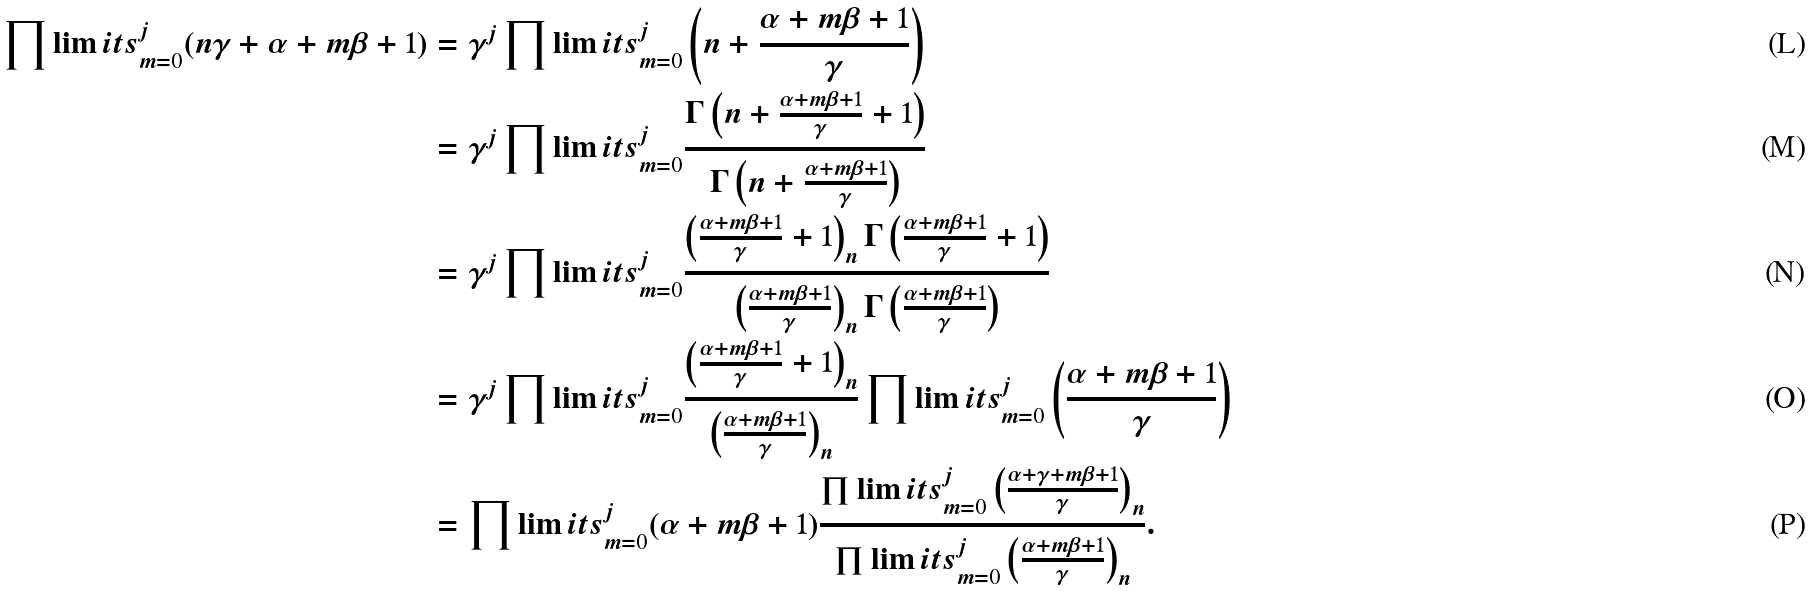Convert formula to latex. <formula><loc_0><loc_0><loc_500><loc_500>\prod \lim i t s _ { m = 0 } ^ { j } ( n \gamma + \alpha + m \beta + 1 ) & = \gamma ^ { j } \prod \lim i t s _ { m = 0 } ^ { j } \left ( n + \frac { \alpha + m \beta + 1 } { \gamma } \right ) \\ & = \gamma ^ { j } \prod \lim i t s _ { m = 0 } ^ { j } \frac { \Gamma \left ( n + \frac { \alpha + m \beta + 1 } { \gamma } + 1 \right ) } { \Gamma \left ( n + \frac { \alpha + m \beta + 1 } { \gamma } \right ) } \\ & = \gamma ^ { j } \prod \lim i t s _ { m = 0 } ^ { j } \frac { \left ( \frac { \alpha + m \beta + 1 } { \gamma } + 1 \right ) _ { n } \Gamma \left ( \frac { \alpha + m \beta + 1 } { \gamma } + 1 \right ) } { \left ( \frac { \alpha + m \beta + 1 } { \gamma } \right ) _ { n } \Gamma \left ( \frac { \alpha + m \beta + 1 } { \gamma } \right ) } \\ & = \gamma ^ { j } \prod \lim i t s _ { m = 0 } ^ { j } \frac { \left ( \frac { \alpha + m \beta + 1 } { \gamma } + 1 \right ) _ { n } } { \left ( \frac { \alpha + m \beta + 1 } { \gamma } \right ) _ { n } } \prod \lim i t s _ { m = 0 } ^ { j } \left ( \frac { \alpha + m \beta + 1 } { \gamma } \right ) \\ & = \prod \lim i t s _ { m = 0 } ^ { j } ( \alpha + m \beta + 1 ) \frac { \prod \lim i t s _ { m = 0 } ^ { j } \left ( \frac { \alpha + \gamma + m \beta + 1 } { \gamma } \right ) _ { n } } { \prod \lim i t s _ { m = 0 } ^ { j } \left ( \frac { \alpha + m \beta + 1 } { \gamma } \right ) _ { n } } .</formula> 